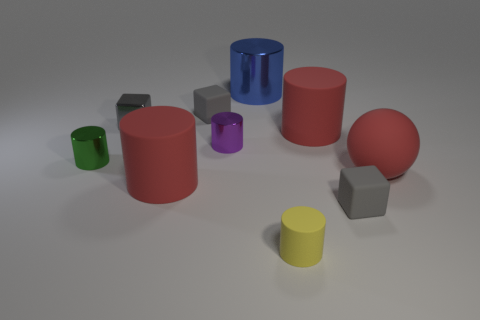Is the tiny metallic block the same color as the tiny matte cylinder?
Give a very brief answer. No. There is a ball; does it have the same color as the rubber cylinder that is on the left side of the big metallic object?
Your answer should be compact. Yes. Is there any other thing that is the same shape as the big blue metal object?
Give a very brief answer. Yes. The matte object right of the small gray rubber block that is in front of the large ball is what color?
Provide a short and direct response. Red. How many tiny gray metal blocks are there?
Your answer should be compact. 1. How many rubber things are either blue cylinders or tiny cubes?
Give a very brief answer. 2. How many cylinders are the same color as the big matte ball?
Ensure brevity in your answer.  2. What is the block that is in front of the large object to the left of the purple thing made of?
Ensure brevity in your answer.  Rubber. The yellow matte cylinder is what size?
Make the answer very short. Small. How many rubber things are the same size as the gray metal block?
Offer a terse response. 3. 